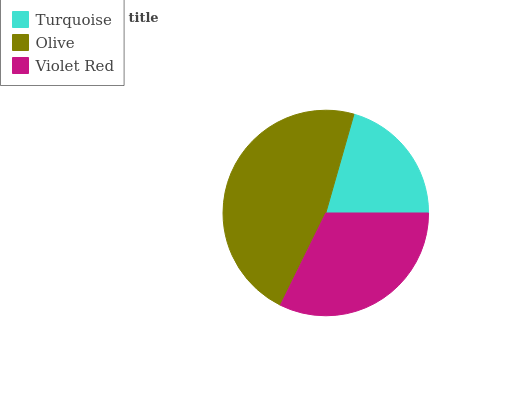Is Turquoise the minimum?
Answer yes or no. Yes. Is Olive the maximum?
Answer yes or no. Yes. Is Violet Red the minimum?
Answer yes or no. No. Is Violet Red the maximum?
Answer yes or no. No. Is Olive greater than Violet Red?
Answer yes or no. Yes. Is Violet Red less than Olive?
Answer yes or no. Yes. Is Violet Red greater than Olive?
Answer yes or no. No. Is Olive less than Violet Red?
Answer yes or no. No. Is Violet Red the high median?
Answer yes or no. Yes. Is Violet Red the low median?
Answer yes or no. Yes. Is Turquoise the high median?
Answer yes or no. No. Is Turquoise the low median?
Answer yes or no. No. 